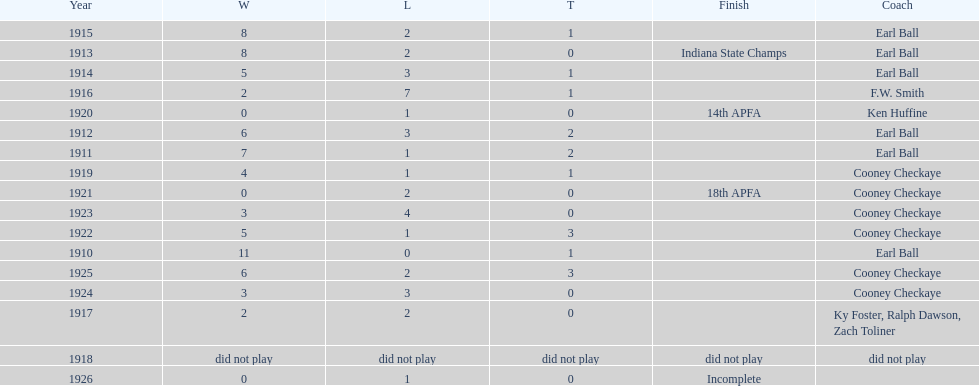Who coached the muncie flyers to an indiana state championship? Earl Ball. 